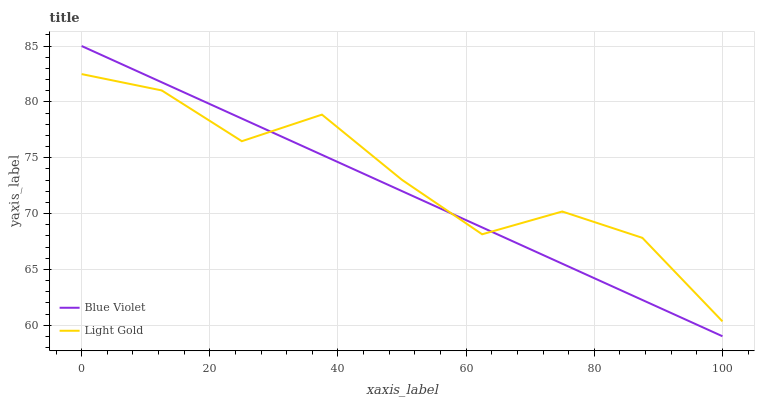Does Blue Violet have the minimum area under the curve?
Answer yes or no. Yes. Does Light Gold have the maximum area under the curve?
Answer yes or no. Yes. Does Blue Violet have the maximum area under the curve?
Answer yes or no. No. Is Blue Violet the smoothest?
Answer yes or no. Yes. Is Light Gold the roughest?
Answer yes or no. Yes. Is Blue Violet the roughest?
Answer yes or no. No. Does Blue Violet have the lowest value?
Answer yes or no. Yes. Does Blue Violet have the highest value?
Answer yes or no. Yes. Does Light Gold intersect Blue Violet?
Answer yes or no. Yes. Is Light Gold less than Blue Violet?
Answer yes or no. No. Is Light Gold greater than Blue Violet?
Answer yes or no. No. 